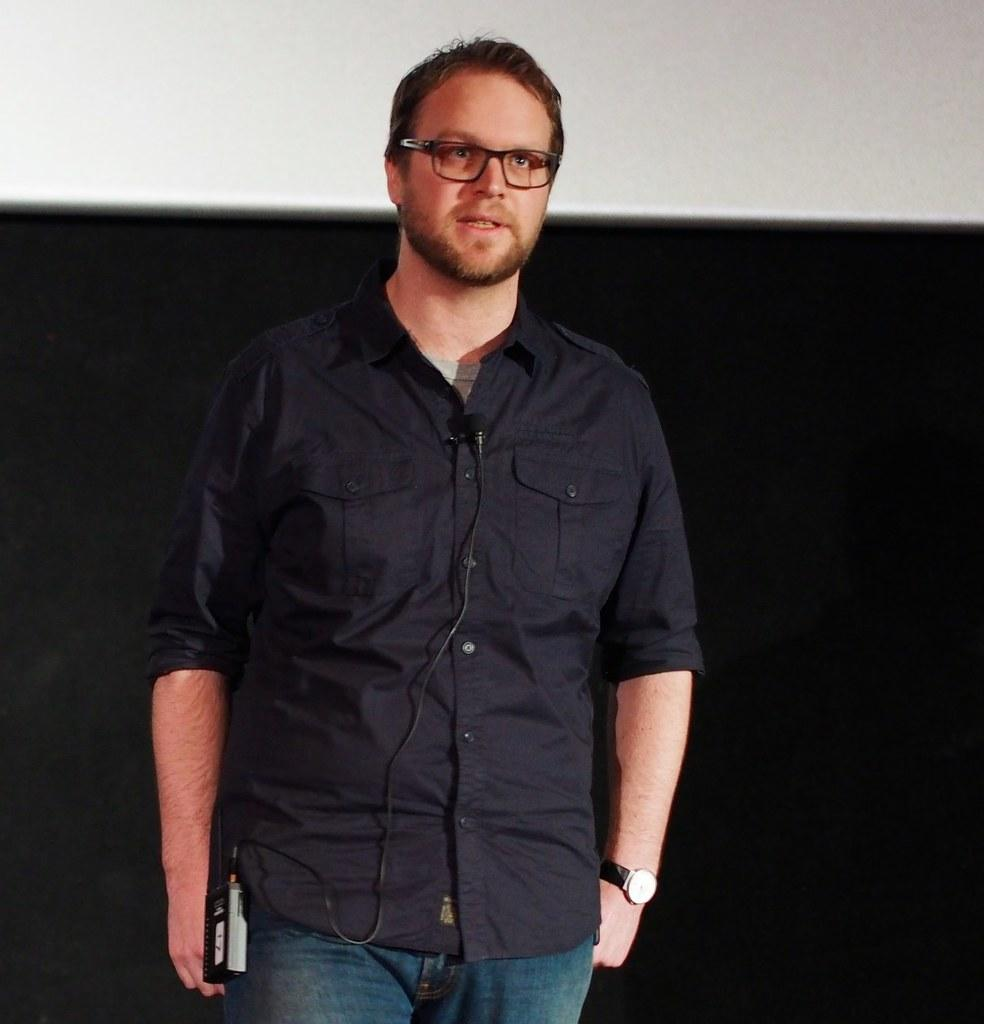What is the main subject of the image? There is a person in the image. What is the person wearing? The person is wearing a black shirt. What is the person's posture in the image? The person is standing. What accessory can be seen on the person's wrist? The person is wearing a watch. How would you describe the color scheme of the image? The background of the image is in black and white color. What type of sheet is being used to sort the springs in the image? There is no sheet or springs present in the image; it features a person wearing a black shirt and standing. 